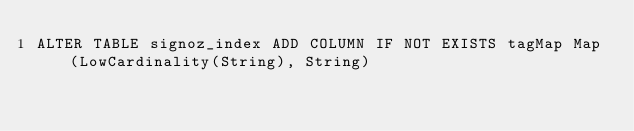Convert code to text. <code><loc_0><loc_0><loc_500><loc_500><_SQL_>ALTER TABLE signoz_index ADD COLUMN IF NOT EXISTS tagMap Map(LowCardinality(String), String)</code> 